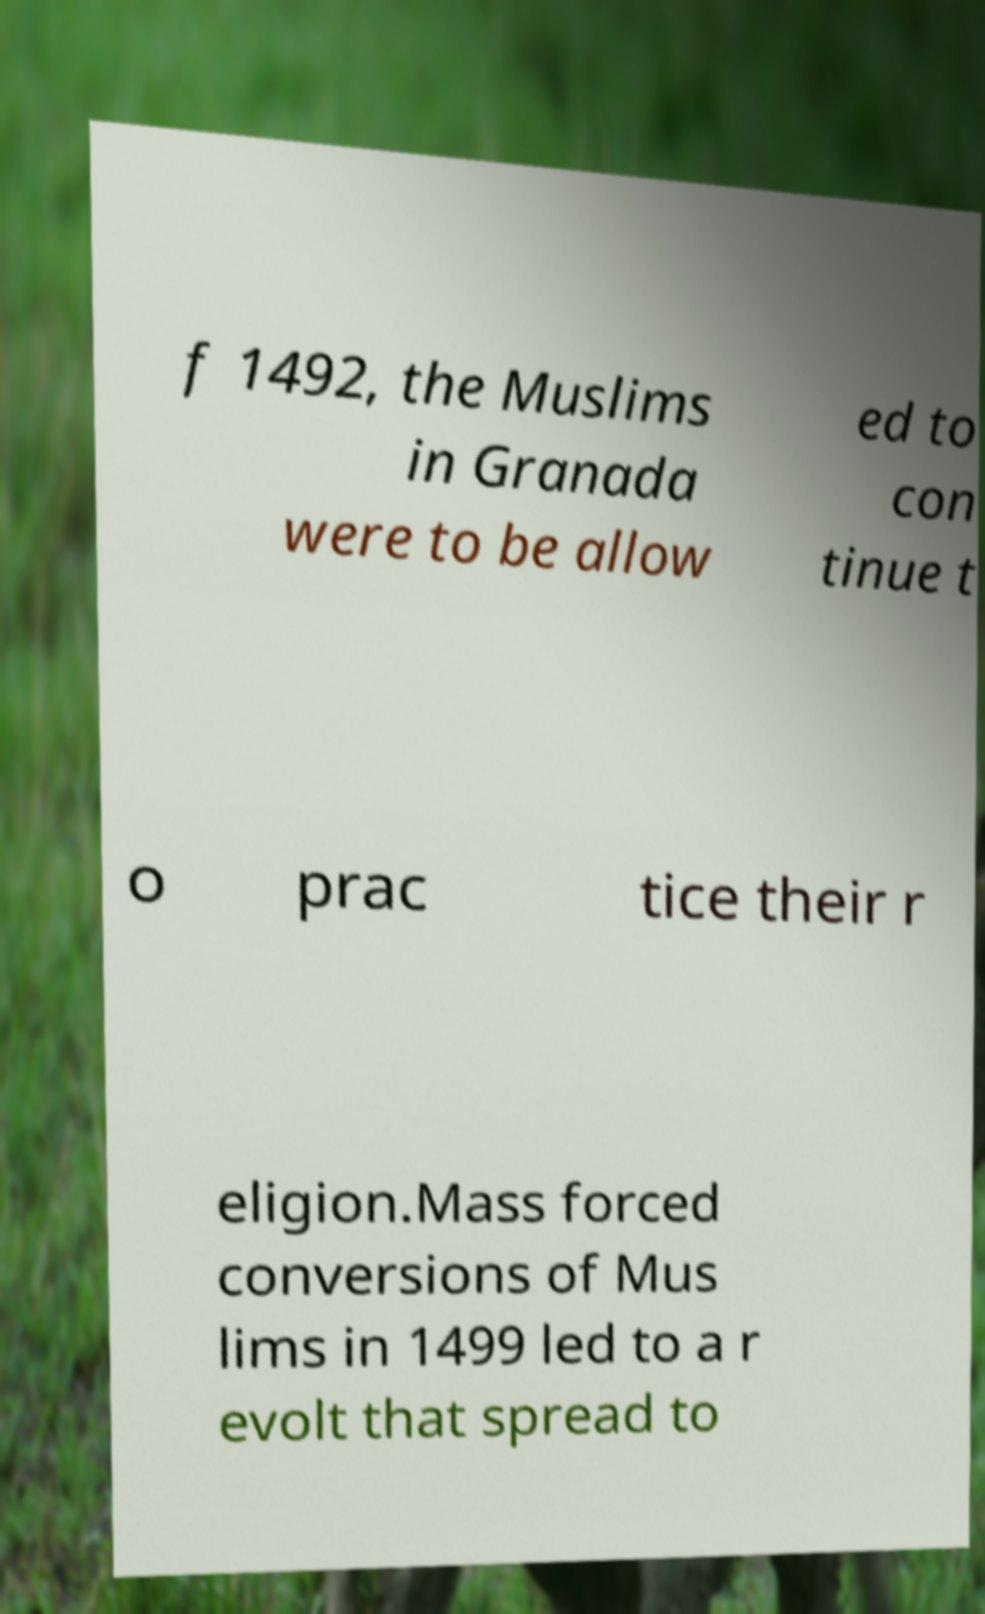Please identify and transcribe the text found in this image. f 1492, the Muslims in Granada were to be allow ed to con tinue t o prac tice their r eligion.Mass forced conversions of Mus lims in 1499 led to a r evolt that spread to 